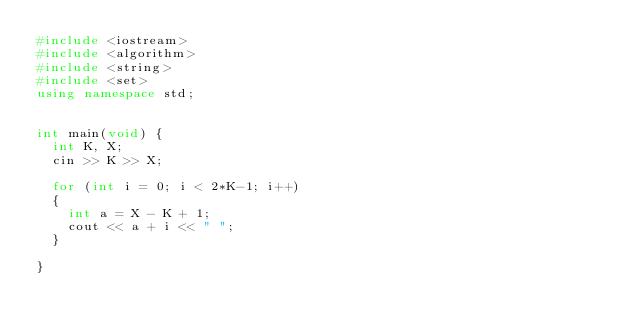Convert code to text. <code><loc_0><loc_0><loc_500><loc_500><_C++_>#include <iostream>
#include <algorithm>
#include <string>
#include <set>
using namespace std;


int main(void) {
	int K, X;
	cin >> K >> X;

	for (int i = 0; i < 2*K-1; i++)
	{
		int a = X - K + 1;
		cout << a + i << " ";
	}
	
}</code> 